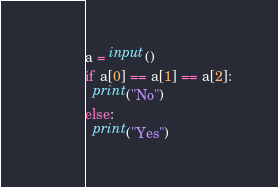Convert code to text. <code><loc_0><loc_0><loc_500><loc_500><_Python_>a = input()
if a[0] == a[1] == a[2]:
  print("No")
else:
  print("Yes")</code> 